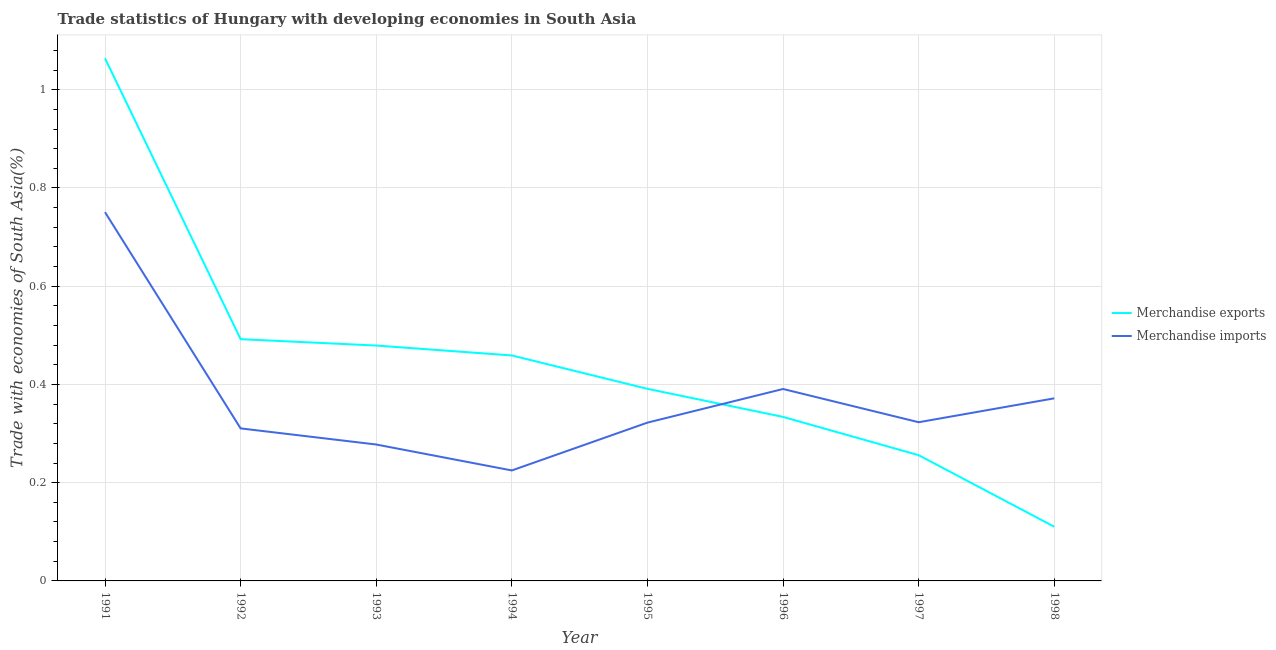Does the line corresponding to merchandise imports intersect with the line corresponding to merchandise exports?
Your answer should be compact. Yes. Is the number of lines equal to the number of legend labels?
Your answer should be compact. Yes. What is the merchandise exports in 1998?
Your response must be concise. 0.11. Across all years, what is the maximum merchandise exports?
Provide a short and direct response. 1.06. Across all years, what is the minimum merchandise exports?
Provide a succinct answer. 0.11. In which year was the merchandise exports maximum?
Ensure brevity in your answer.  1991. In which year was the merchandise exports minimum?
Keep it short and to the point. 1998. What is the total merchandise exports in the graph?
Offer a terse response. 3.59. What is the difference between the merchandise imports in 1992 and that in 1997?
Your response must be concise. -0.01. What is the difference between the merchandise exports in 1991 and the merchandise imports in 1992?
Ensure brevity in your answer.  0.75. What is the average merchandise exports per year?
Provide a succinct answer. 0.45. In the year 1991, what is the difference between the merchandise imports and merchandise exports?
Give a very brief answer. -0.31. What is the ratio of the merchandise imports in 1991 to that in 1997?
Your response must be concise. 2.32. What is the difference between the highest and the second highest merchandise exports?
Offer a very short reply. 0.57. What is the difference between the highest and the lowest merchandise imports?
Keep it short and to the point. 0.53. In how many years, is the merchandise exports greater than the average merchandise exports taken over all years?
Make the answer very short. 4. Is the sum of the merchandise exports in 1994 and 1996 greater than the maximum merchandise imports across all years?
Offer a very short reply. Yes. Is the merchandise imports strictly less than the merchandise exports over the years?
Provide a short and direct response. No. How many years are there in the graph?
Your answer should be compact. 8. What is the difference between two consecutive major ticks on the Y-axis?
Your response must be concise. 0.2. Does the graph contain grids?
Ensure brevity in your answer.  Yes. Where does the legend appear in the graph?
Provide a succinct answer. Center right. How are the legend labels stacked?
Provide a succinct answer. Vertical. What is the title of the graph?
Provide a succinct answer. Trade statistics of Hungary with developing economies in South Asia. Does "From human activities" appear as one of the legend labels in the graph?
Provide a succinct answer. No. What is the label or title of the X-axis?
Offer a terse response. Year. What is the label or title of the Y-axis?
Your answer should be very brief. Trade with economies of South Asia(%). What is the Trade with economies of South Asia(%) in Merchandise exports in 1991?
Ensure brevity in your answer.  1.06. What is the Trade with economies of South Asia(%) in Merchandise imports in 1991?
Your answer should be very brief. 0.75. What is the Trade with economies of South Asia(%) in Merchandise exports in 1992?
Provide a short and direct response. 0.49. What is the Trade with economies of South Asia(%) in Merchandise imports in 1992?
Ensure brevity in your answer.  0.31. What is the Trade with economies of South Asia(%) in Merchandise exports in 1993?
Give a very brief answer. 0.48. What is the Trade with economies of South Asia(%) in Merchandise imports in 1993?
Your answer should be compact. 0.28. What is the Trade with economies of South Asia(%) in Merchandise exports in 1994?
Provide a short and direct response. 0.46. What is the Trade with economies of South Asia(%) of Merchandise imports in 1994?
Offer a very short reply. 0.22. What is the Trade with economies of South Asia(%) in Merchandise exports in 1995?
Make the answer very short. 0.39. What is the Trade with economies of South Asia(%) of Merchandise imports in 1995?
Provide a succinct answer. 0.32. What is the Trade with economies of South Asia(%) of Merchandise exports in 1996?
Make the answer very short. 0.33. What is the Trade with economies of South Asia(%) in Merchandise imports in 1996?
Make the answer very short. 0.39. What is the Trade with economies of South Asia(%) of Merchandise exports in 1997?
Ensure brevity in your answer.  0.26. What is the Trade with economies of South Asia(%) in Merchandise imports in 1997?
Make the answer very short. 0.32. What is the Trade with economies of South Asia(%) of Merchandise exports in 1998?
Provide a short and direct response. 0.11. What is the Trade with economies of South Asia(%) of Merchandise imports in 1998?
Keep it short and to the point. 0.37. Across all years, what is the maximum Trade with economies of South Asia(%) in Merchandise exports?
Give a very brief answer. 1.06. Across all years, what is the maximum Trade with economies of South Asia(%) in Merchandise imports?
Ensure brevity in your answer.  0.75. Across all years, what is the minimum Trade with economies of South Asia(%) of Merchandise exports?
Give a very brief answer. 0.11. Across all years, what is the minimum Trade with economies of South Asia(%) of Merchandise imports?
Give a very brief answer. 0.22. What is the total Trade with economies of South Asia(%) of Merchandise exports in the graph?
Provide a succinct answer. 3.59. What is the total Trade with economies of South Asia(%) in Merchandise imports in the graph?
Your answer should be compact. 2.97. What is the difference between the Trade with economies of South Asia(%) of Merchandise exports in 1991 and that in 1992?
Offer a very short reply. 0.57. What is the difference between the Trade with economies of South Asia(%) in Merchandise imports in 1991 and that in 1992?
Your answer should be very brief. 0.44. What is the difference between the Trade with economies of South Asia(%) in Merchandise exports in 1991 and that in 1993?
Make the answer very short. 0.58. What is the difference between the Trade with economies of South Asia(%) in Merchandise imports in 1991 and that in 1993?
Give a very brief answer. 0.47. What is the difference between the Trade with economies of South Asia(%) in Merchandise exports in 1991 and that in 1994?
Keep it short and to the point. 0.6. What is the difference between the Trade with economies of South Asia(%) in Merchandise imports in 1991 and that in 1994?
Your response must be concise. 0.53. What is the difference between the Trade with economies of South Asia(%) in Merchandise exports in 1991 and that in 1995?
Your answer should be compact. 0.67. What is the difference between the Trade with economies of South Asia(%) in Merchandise imports in 1991 and that in 1995?
Provide a short and direct response. 0.43. What is the difference between the Trade with economies of South Asia(%) of Merchandise exports in 1991 and that in 1996?
Your answer should be compact. 0.73. What is the difference between the Trade with economies of South Asia(%) of Merchandise imports in 1991 and that in 1996?
Provide a succinct answer. 0.36. What is the difference between the Trade with economies of South Asia(%) of Merchandise exports in 1991 and that in 1997?
Give a very brief answer. 0.81. What is the difference between the Trade with economies of South Asia(%) of Merchandise imports in 1991 and that in 1997?
Give a very brief answer. 0.43. What is the difference between the Trade with economies of South Asia(%) of Merchandise exports in 1991 and that in 1998?
Your response must be concise. 0.95. What is the difference between the Trade with economies of South Asia(%) of Merchandise imports in 1991 and that in 1998?
Your response must be concise. 0.38. What is the difference between the Trade with economies of South Asia(%) of Merchandise exports in 1992 and that in 1993?
Provide a succinct answer. 0.01. What is the difference between the Trade with economies of South Asia(%) in Merchandise imports in 1992 and that in 1993?
Provide a succinct answer. 0.03. What is the difference between the Trade with economies of South Asia(%) in Merchandise exports in 1992 and that in 1994?
Ensure brevity in your answer.  0.03. What is the difference between the Trade with economies of South Asia(%) of Merchandise imports in 1992 and that in 1994?
Provide a succinct answer. 0.09. What is the difference between the Trade with economies of South Asia(%) of Merchandise exports in 1992 and that in 1995?
Keep it short and to the point. 0.1. What is the difference between the Trade with economies of South Asia(%) of Merchandise imports in 1992 and that in 1995?
Offer a very short reply. -0.01. What is the difference between the Trade with economies of South Asia(%) in Merchandise exports in 1992 and that in 1996?
Your answer should be compact. 0.16. What is the difference between the Trade with economies of South Asia(%) in Merchandise imports in 1992 and that in 1996?
Ensure brevity in your answer.  -0.08. What is the difference between the Trade with economies of South Asia(%) of Merchandise exports in 1992 and that in 1997?
Your answer should be compact. 0.24. What is the difference between the Trade with economies of South Asia(%) of Merchandise imports in 1992 and that in 1997?
Provide a succinct answer. -0.01. What is the difference between the Trade with economies of South Asia(%) in Merchandise exports in 1992 and that in 1998?
Give a very brief answer. 0.38. What is the difference between the Trade with economies of South Asia(%) in Merchandise imports in 1992 and that in 1998?
Make the answer very short. -0.06. What is the difference between the Trade with economies of South Asia(%) in Merchandise exports in 1993 and that in 1994?
Your answer should be compact. 0.02. What is the difference between the Trade with economies of South Asia(%) of Merchandise imports in 1993 and that in 1994?
Provide a succinct answer. 0.05. What is the difference between the Trade with economies of South Asia(%) in Merchandise exports in 1993 and that in 1995?
Your answer should be compact. 0.09. What is the difference between the Trade with economies of South Asia(%) of Merchandise imports in 1993 and that in 1995?
Your response must be concise. -0.04. What is the difference between the Trade with economies of South Asia(%) of Merchandise exports in 1993 and that in 1996?
Make the answer very short. 0.15. What is the difference between the Trade with economies of South Asia(%) of Merchandise imports in 1993 and that in 1996?
Offer a terse response. -0.11. What is the difference between the Trade with economies of South Asia(%) of Merchandise exports in 1993 and that in 1997?
Offer a terse response. 0.22. What is the difference between the Trade with economies of South Asia(%) of Merchandise imports in 1993 and that in 1997?
Provide a short and direct response. -0.05. What is the difference between the Trade with economies of South Asia(%) in Merchandise exports in 1993 and that in 1998?
Your response must be concise. 0.37. What is the difference between the Trade with economies of South Asia(%) in Merchandise imports in 1993 and that in 1998?
Ensure brevity in your answer.  -0.09. What is the difference between the Trade with economies of South Asia(%) of Merchandise exports in 1994 and that in 1995?
Your answer should be compact. 0.07. What is the difference between the Trade with economies of South Asia(%) in Merchandise imports in 1994 and that in 1995?
Make the answer very short. -0.1. What is the difference between the Trade with economies of South Asia(%) in Merchandise exports in 1994 and that in 1996?
Provide a succinct answer. 0.13. What is the difference between the Trade with economies of South Asia(%) in Merchandise imports in 1994 and that in 1996?
Keep it short and to the point. -0.17. What is the difference between the Trade with economies of South Asia(%) in Merchandise exports in 1994 and that in 1997?
Keep it short and to the point. 0.2. What is the difference between the Trade with economies of South Asia(%) of Merchandise imports in 1994 and that in 1997?
Offer a terse response. -0.1. What is the difference between the Trade with economies of South Asia(%) of Merchandise exports in 1994 and that in 1998?
Make the answer very short. 0.35. What is the difference between the Trade with economies of South Asia(%) in Merchandise imports in 1994 and that in 1998?
Keep it short and to the point. -0.15. What is the difference between the Trade with economies of South Asia(%) of Merchandise exports in 1995 and that in 1996?
Offer a very short reply. 0.06. What is the difference between the Trade with economies of South Asia(%) in Merchandise imports in 1995 and that in 1996?
Your response must be concise. -0.07. What is the difference between the Trade with economies of South Asia(%) of Merchandise exports in 1995 and that in 1997?
Your response must be concise. 0.14. What is the difference between the Trade with economies of South Asia(%) in Merchandise imports in 1995 and that in 1997?
Ensure brevity in your answer.  -0. What is the difference between the Trade with economies of South Asia(%) of Merchandise exports in 1995 and that in 1998?
Offer a very short reply. 0.28. What is the difference between the Trade with economies of South Asia(%) in Merchandise imports in 1995 and that in 1998?
Ensure brevity in your answer.  -0.05. What is the difference between the Trade with economies of South Asia(%) in Merchandise exports in 1996 and that in 1997?
Give a very brief answer. 0.08. What is the difference between the Trade with economies of South Asia(%) of Merchandise imports in 1996 and that in 1997?
Offer a terse response. 0.07. What is the difference between the Trade with economies of South Asia(%) in Merchandise exports in 1996 and that in 1998?
Offer a very short reply. 0.22. What is the difference between the Trade with economies of South Asia(%) of Merchandise imports in 1996 and that in 1998?
Give a very brief answer. 0.02. What is the difference between the Trade with economies of South Asia(%) in Merchandise exports in 1997 and that in 1998?
Offer a terse response. 0.15. What is the difference between the Trade with economies of South Asia(%) in Merchandise imports in 1997 and that in 1998?
Keep it short and to the point. -0.05. What is the difference between the Trade with economies of South Asia(%) in Merchandise exports in 1991 and the Trade with economies of South Asia(%) in Merchandise imports in 1992?
Your answer should be very brief. 0.75. What is the difference between the Trade with economies of South Asia(%) in Merchandise exports in 1991 and the Trade with economies of South Asia(%) in Merchandise imports in 1993?
Your answer should be very brief. 0.79. What is the difference between the Trade with economies of South Asia(%) in Merchandise exports in 1991 and the Trade with economies of South Asia(%) in Merchandise imports in 1994?
Make the answer very short. 0.84. What is the difference between the Trade with economies of South Asia(%) of Merchandise exports in 1991 and the Trade with economies of South Asia(%) of Merchandise imports in 1995?
Ensure brevity in your answer.  0.74. What is the difference between the Trade with economies of South Asia(%) of Merchandise exports in 1991 and the Trade with economies of South Asia(%) of Merchandise imports in 1996?
Your answer should be very brief. 0.67. What is the difference between the Trade with economies of South Asia(%) of Merchandise exports in 1991 and the Trade with economies of South Asia(%) of Merchandise imports in 1997?
Provide a succinct answer. 0.74. What is the difference between the Trade with economies of South Asia(%) in Merchandise exports in 1991 and the Trade with economies of South Asia(%) in Merchandise imports in 1998?
Keep it short and to the point. 0.69. What is the difference between the Trade with economies of South Asia(%) of Merchandise exports in 1992 and the Trade with economies of South Asia(%) of Merchandise imports in 1993?
Ensure brevity in your answer.  0.21. What is the difference between the Trade with economies of South Asia(%) of Merchandise exports in 1992 and the Trade with economies of South Asia(%) of Merchandise imports in 1994?
Offer a terse response. 0.27. What is the difference between the Trade with economies of South Asia(%) in Merchandise exports in 1992 and the Trade with economies of South Asia(%) in Merchandise imports in 1995?
Ensure brevity in your answer.  0.17. What is the difference between the Trade with economies of South Asia(%) in Merchandise exports in 1992 and the Trade with economies of South Asia(%) in Merchandise imports in 1996?
Offer a very short reply. 0.1. What is the difference between the Trade with economies of South Asia(%) of Merchandise exports in 1992 and the Trade with economies of South Asia(%) of Merchandise imports in 1997?
Your response must be concise. 0.17. What is the difference between the Trade with economies of South Asia(%) of Merchandise exports in 1992 and the Trade with economies of South Asia(%) of Merchandise imports in 1998?
Keep it short and to the point. 0.12. What is the difference between the Trade with economies of South Asia(%) in Merchandise exports in 1993 and the Trade with economies of South Asia(%) in Merchandise imports in 1994?
Offer a very short reply. 0.25. What is the difference between the Trade with economies of South Asia(%) of Merchandise exports in 1993 and the Trade with economies of South Asia(%) of Merchandise imports in 1995?
Give a very brief answer. 0.16. What is the difference between the Trade with economies of South Asia(%) in Merchandise exports in 1993 and the Trade with economies of South Asia(%) in Merchandise imports in 1996?
Provide a succinct answer. 0.09. What is the difference between the Trade with economies of South Asia(%) in Merchandise exports in 1993 and the Trade with economies of South Asia(%) in Merchandise imports in 1997?
Give a very brief answer. 0.16. What is the difference between the Trade with economies of South Asia(%) of Merchandise exports in 1993 and the Trade with economies of South Asia(%) of Merchandise imports in 1998?
Your answer should be very brief. 0.11. What is the difference between the Trade with economies of South Asia(%) in Merchandise exports in 1994 and the Trade with economies of South Asia(%) in Merchandise imports in 1995?
Offer a very short reply. 0.14. What is the difference between the Trade with economies of South Asia(%) in Merchandise exports in 1994 and the Trade with economies of South Asia(%) in Merchandise imports in 1996?
Offer a terse response. 0.07. What is the difference between the Trade with economies of South Asia(%) of Merchandise exports in 1994 and the Trade with economies of South Asia(%) of Merchandise imports in 1997?
Keep it short and to the point. 0.14. What is the difference between the Trade with economies of South Asia(%) of Merchandise exports in 1994 and the Trade with economies of South Asia(%) of Merchandise imports in 1998?
Your answer should be compact. 0.09. What is the difference between the Trade with economies of South Asia(%) in Merchandise exports in 1995 and the Trade with economies of South Asia(%) in Merchandise imports in 1996?
Provide a succinct answer. 0. What is the difference between the Trade with economies of South Asia(%) in Merchandise exports in 1995 and the Trade with economies of South Asia(%) in Merchandise imports in 1997?
Your answer should be compact. 0.07. What is the difference between the Trade with economies of South Asia(%) in Merchandise exports in 1995 and the Trade with economies of South Asia(%) in Merchandise imports in 1998?
Provide a succinct answer. 0.02. What is the difference between the Trade with economies of South Asia(%) of Merchandise exports in 1996 and the Trade with economies of South Asia(%) of Merchandise imports in 1997?
Keep it short and to the point. 0.01. What is the difference between the Trade with economies of South Asia(%) in Merchandise exports in 1996 and the Trade with economies of South Asia(%) in Merchandise imports in 1998?
Offer a very short reply. -0.04. What is the difference between the Trade with economies of South Asia(%) of Merchandise exports in 1997 and the Trade with economies of South Asia(%) of Merchandise imports in 1998?
Your answer should be very brief. -0.12. What is the average Trade with economies of South Asia(%) in Merchandise exports per year?
Your answer should be very brief. 0.45. What is the average Trade with economies of South Asia(%) of Merchandise imports per year?
Provide a short and direct response. 0.37. In the year 1991, what is the difference between the Trade with economies of South Asia(%) of Merchandise exports and Trade with economies of South Asia(%) of Merchandise imports?
Give a very brief answer. 0.31. In the year 1992, what is the difference between the Trade with economies of South Asia(%) of Merchandise exports and Trade with economies of South Asia(%) of Merchandise imports?
Your response must be concise. 0.18. In the year 1993, what is the difference between the Trade with economies of South Asia(%) in Merchandise exports and Trade with economies of South Asia(%) in Merchandise imports?
Ensure brevity in your answer.  0.2. In the year 1994, what is the difference between the Trade with economies of South Asia(%) in Merchandise exports and Trade with economies of South Asia(%) in Merchandise imports?
Your response must be concise. 0.23. In the year 1995, what is the difference between the Trade with economies of South Asia(%) in Merchandise exports and Trade with economies of South Asia(%) in Merchandise imports?
Provide a short and direct response. 0.07. In the year 1996, what is the difference between the Trade with economies of South Asia(%) in Merchandise exports and Trade with economies of South Asia(%) in Merchandise imports?
Give a very brief answer. -0.06. In the year 1997, what is the difference between the Trade with economies of South Asia(%) in Merchandise exports and Trade with economies of South Asia(%) in Merchandise imports?
Ensure brevity in your answer.  -0.07. In the year 1998, what is the difference between the Trade with economies of South Asia(%) in Merchandise exports and Trade with economies of South Asia(%) in Merchandise imports?
Ensure brevity in your answer.  -0.26. What is the ratio of the Trade with economies of South Asia(%) of Merchandise exports in 1991 to that in 1992?
Provide a short and direct response. 2.16. What is the ratio of the Trade with economies of South Asia(%) in Merchandise imports in 1991 to that in 1992?
Your answer should be compact. 2.42. What is the ratio of the Trade with economies of South Asia(%) of Merchandise exports in 1991 to that in 1993?
Your answer should be very brief. 2.22. What is the ratio of the Trade with economies of South Asia(%) of Merchandise imports in 1991 to that in 1993?
Make the answer very short. 2.7. What is the ratio of the Trade with economies of South Asia(%) in Merchandise exports in 1991 to that in 1994?
Provide a succinct answer. 2.32. What is the ratio of the Trade with economies of South Asia(%) of Merchandise imports in 1991 to that in 1994?
Offer a terse response. 3.34. What is the ratio of the Trade with economies of South Asia(%) in Merchandise exports in 1991 to that in 1995?
Offer a terse response. 2.72. What is the ratio of the Trade with economies of South Asia(%) in Merchandise imports in 1991 to that in 1995?
Ensure brevity in your answer.  2.33. What is the ratio of the Trade with economies of South Asia(%) in Merchandise exports in 1991 to that in 1996?
Your answer should be very brief. 3.19. What is the ratio of the Trade with economies of South Asia(%) in Merchandise imports in 1991 to that in 1996?
Offer a very short reply. 1.92. What is the ratio of the Trade with economies of South Asia(%) of Merchandise exports in 1991 to that in 1997?
Ensure brevity in your answer.  4.16. What is the ratio of the Trade with economies of South Asia(%) of Merchandise imports in 1991 to that in 1997?
Make the answer very short. 2.32. What is the ratio of the Trade with economies of South Asia(%) in Merchandise exports in 1991 to that in 1998?
Give a very brief answer. 9.64. What is the ratio of the Trade with economies of South Asia(%) of Merchandise imports in 1991 to that in 1998?
Keep it short and to the point. 2.02. What is the ratio of the Trade with economies of South Asia(%) of Merchandise exports in 1992 to that in 1993?
Give a very brief answer. 1.03. What is the ratio of the Trade with economies of South Asia(%) in Merchandise imports in 1992 to that in 1993?
Your response must be concise. 1.12. What is the ratio of the Trade with economies of South Asia(%) in Merchandise exports in 1992 to that in 1994?
Ensure brevity in your answer.  1.07. What is the ratio of the Trade with economies of South Asia(%) in Merchandise imports in 1992 to that in 1994?
Offer a very short reply. 1.38. What is the ratio of the Trade with economies of South Asia(%) of Merchandise exports in 1992 to that in 1995?
Provide a succinct answer. 1.26. What is the ratio of the Trade with economies of South Asia(%) in Merchandise imports in 1992 to that in 1995?
Your answer should be compact. 0.96. What is the ratio of the Trade with economies of South Asia(%) in Merchandise exports in 1992 to that in 1996?
Your response must be concise. 1.47. What is the ratio of the Trade with economies of South Asia(%) in Merchandise imports in 1992 to that in 1996?
Your answer should be very brief. 0.79. What is the ratio of the Trade with economies of South Asia(%) in Merchandise exports in 1992 to that in 1997?
Offer a very short reply. 1.92. What is the ratio of the Trade with economies of South Asia(%) in Merchandise imports in 1992 to that in 1997?
Your answer should be very brief. 0.96. What is the ratio of the Trade with economies of South Asia(%) in Merchandise exports in 1992 to that in 1998?
Offer a terse response. 4.46. What is the ratio of the Trade with economies of South Asia(%) in Merchandise imports in 1992 to that in 1998?
Your response must be concise. 0.84. What is the ratio of the Trade with economies of South Asia(%) of Merchandise exports in 1993 to that in 1994?
Ensure brevity in your answer.  1.04. What is the ratio of the Trade with economies of South Asia(%) of Merchandise imports in 1993 to that in 1994?
Make the answer very short. 1.23. What is the ratio of the Trade with economies of South Asia(%) in Merchandise exports in 1993 to that in 1995?
Make the answer very short. 1.23. What is the ratio of the Trade with economies of South Asia(%) of Merchandise imports in 1993 to that in 1995?
Provide a short and direct response. 0.86. What is the ratio of the Trade with economies of South Asia(%) of Merchandise exports in 1993 to that in 1996?
Provide a succinct answer. 1.44. What is the ratio of the Trade with economies of South Asia(%) in Merchandise imports in 1993 to that in 1996?
Your answer should be compact. 0.71. What is the ratio of the Trade with economies of South Asia(%) of Merchandise exports in 1993 to that in 1997?
Make the answer very short. 1.87. What is the ratio of the Trade with economies of South Asia(%) of Merchandise imports in 1993 to that in 1997?
Ensure brevity in your answer.  0.86. What is the ratio of the Trade with economies of South Asia(%) in Merchandise exports in 1993 to that in 1998?
Ensure brevity in your answer.  4.34. What is the ratio of the Trade with economies of South Asia(%) in Merchandise imports in 1993 to that in 1998?
Ensure brevity in your answer.  0.75. What is the ratio of the Trade with economies of South Asia(%) in Merchandise exports in 1994 to that in 1995?
Your response must be concise. 1.17. What is the ratio of the Trade with economies of South Asia(%) of Merchandise imports in 1994 to that in 1995?
Your answer should be compact. 0.7. What is the ratio of the Trade with economies of South Asia(%) of Merchandise exports in 1994 to that in 1996?
Give a very brief answer. 1.37. What is the ratio of the Trade with economies of South Asia(%) of Merchandise imports in 1994 to that in 1996?
Make the answer very short. 0.58. What is the ratio of the Trade with economies of South Asia(%) in Merchandise exports in 1994 to that in 1997?
Your answer should be compact. 1.79. What is the ratio of the Trade with economies of South Asia(%) in Merchandise imports in 1994 to that in 1997?
Your answer should be compact. 0.7. What is the ratio of the Trade with economies of South Asia(%) of Merchandise exports in 1994 to that in 1998?
Your answer should be very brief. 4.16. What is the ratio of the Trade with economies of South Asia(%) in Merchandise imports in 1994 to that in 1998?
Your answer should be very brief. 0.61. What is the ratio of the Trade with economies of South Asia(%) in Merchandise exports in 1995 to that in 1996?
Your response must be concise. 1.17. What is the ratio of the Trade with economies of South Asia(%) in Merchandise imports in 1995 to that in 1996?
Give a very brief answer. 0.82. What is the ratio of the Trade with economies of South Asia(%) in Merchandise exports in 1995 to that in 1997?
Offer a terse response. 1.53. What is the ratio of the Trade with economies of South Asia(%) of Merchandise imports in 1995 to that in 1997?
Make the answer very short. 1. What is the ratio of the Trade with economies of South Asia(%) of Merchandise exports in 1995 to that in 1998?
Provide a short and direct response. 3.54. What is the ratio of the Trade with economies of South Asia(%) of Merchandise imports in 1995 to that in 1998?
Your answer should be very brief. 0.87. What is the ratio of the Trade with economies of South Asia(%) in Merchandise exports in 1996 to that in 1997?
Ensure brevity in your answer.  1.3. What is the ratio of the Trade with economies of South Asia(%) of Merchandise imports in 1996 to that in 1997?
Your answer should be very brief. 1.21. What is the ratio of the Trade with economies of South Asia(%) of Merchandise exports in 1996 to that in 1998?
Offer a very short reply. 3.03. What is the ratio of the Trade with economies of South Asia(%) in Merchandise imports in 1996 to that in 1998?
Ensure brevity in your answer.  1.05. What is the ratio of the Trade with economies of South Asia(%) of Merchandise exports in 1997 to that in 1998?
Make the answer very short. 2.32. What is the ratio of the Trade with economies of South Asia(%) of Merchandise imports in 1997 to that in 1998?
Offer a very short reply. 0.87. What is the difference between the highest and the second highest Trade with economies of South Asia(%) in Merchandise exports?
Provide a short and direct response. 0.57. What is the difference between the highest and the second highest Trade with economies of South Asia(%) in Merchandise imports?
Make the answer very short. 0.36. What is the difference between the highest and the lowest Trade with economies of South Asia(%) of Merchandise exports?
Make the answer very short. 0.95. What is the difference between the highest and the lowest Trade with economies of South Asia(%) in Merchandise imports?
Offer a terse response. 0.53. 